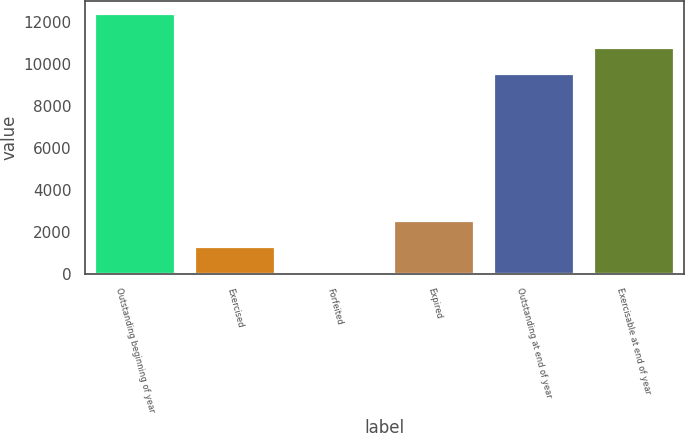Convert chart. <chart><loc_0><loc_0><loc_500><loc_500><bar_chart><fcel>Outstanding beginning of year<fcel>Exercised<fcel>Forfeited<fcel>Expired<fcel>Outstanding at end of year<fcel>Exercisable at end of year<nl><fcel>12374<fcel>1282.4<fcel>50<fcel>2514.8<fcel>9547<fcel>10779.4<nl></chart> 